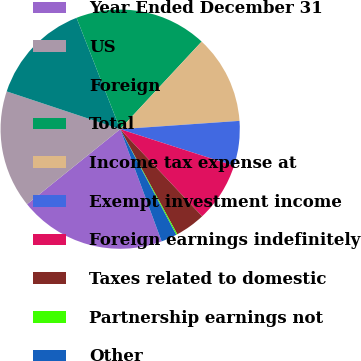Convert chart. <chart><loc_0><loc_0><loc_500><loc_500><pie_chart><fcel>Year Ended December 31<fcel>US<fcel>Foreign<fcel>Total<fcel>Income tax expense at<fcel>Exempt investment income<fcel>Foreign earnings indefinitely<fcel>Taxes related to domestic<fcel>Partnership earnings not<fcel>Other<nl><fcel>19.84%<fcel>15.91%<fcel>13.94%<fcel>17.87%<fcel>11.97%<fcel>6.06%<fcel>8.03%<fcel>4.09%<fcel>0.16%<fcel>2.13%<nl></chart> 